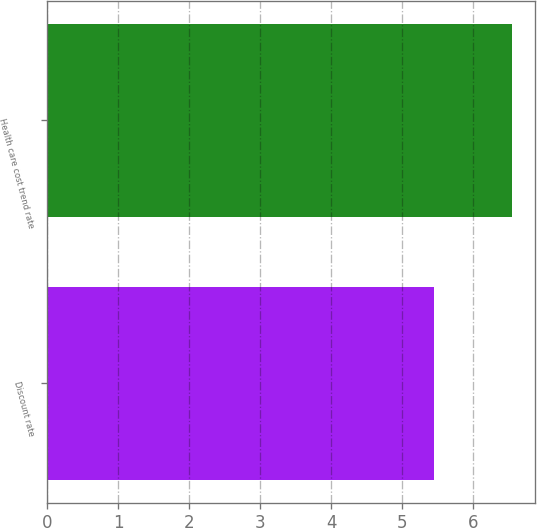Convert chart. <chart><loc_0><loc_0><loc_500><loc_500><bar_chart><fcel>Discount rate<fcel>Health care cost trend rate<nl><fcel>5.45<fcel>6.55<nl></chart> 